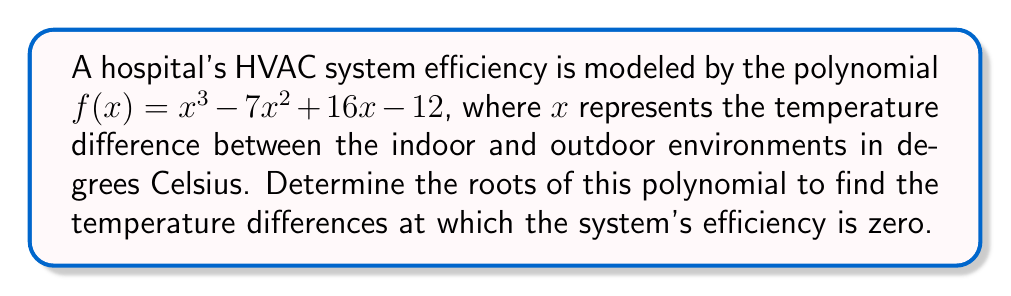Show me your answer to this math problem. To find the roots of the polynomial $f(x) = x^3 - 7x^2 + 16x - 12$, we need to factor it.

1) First, let's check if there's a rational root using the rational root theorem. The possible rational roots are the factors of the constant term: $\pm1, \pm2, \pm3, \pm4, \pm6, \pm12$.

2) Testing these values, we find that $f(1) = 0$. So, $(x-1)$ is a factor.

3) We can use polynomial long division to divide $f(x)$ by $(x-1)$:

   $$\frac{x^3 - 7x^2 + 16x - 12}{x-1} = x^2 - 6x + 10$$

4) So, $f(x) = (x-1)(x^2 - 6x + 10)$

5) Now we need to factor $x^2 - 6x + 10$. We can use the quadratic formula:
   
   $$x = \frac{-b \pm \sqrt{b^2 - 4ac}}{2a}$$

   where $a=1$, $b=-6$, and $c=10$

6) Substituting these values:

   $$x = \frac{6 \pm \sqrt{36 - 40}}{2} = \frac{6 \pm \sqrt{-4}}{2} = \frac{6 \pm 2i}{2} = 3 \pm i$$

7) Therefore, the complete factorization is:

   $$f(x) = (x-1)(x-3-i)(x-3+i)$$

The roots of the polynomial are 1, $3+i$, and $3-i$.
Answer: The roots of the polynomial are $x = 1$, $x = 3+i$, and $x = 3-i$. 